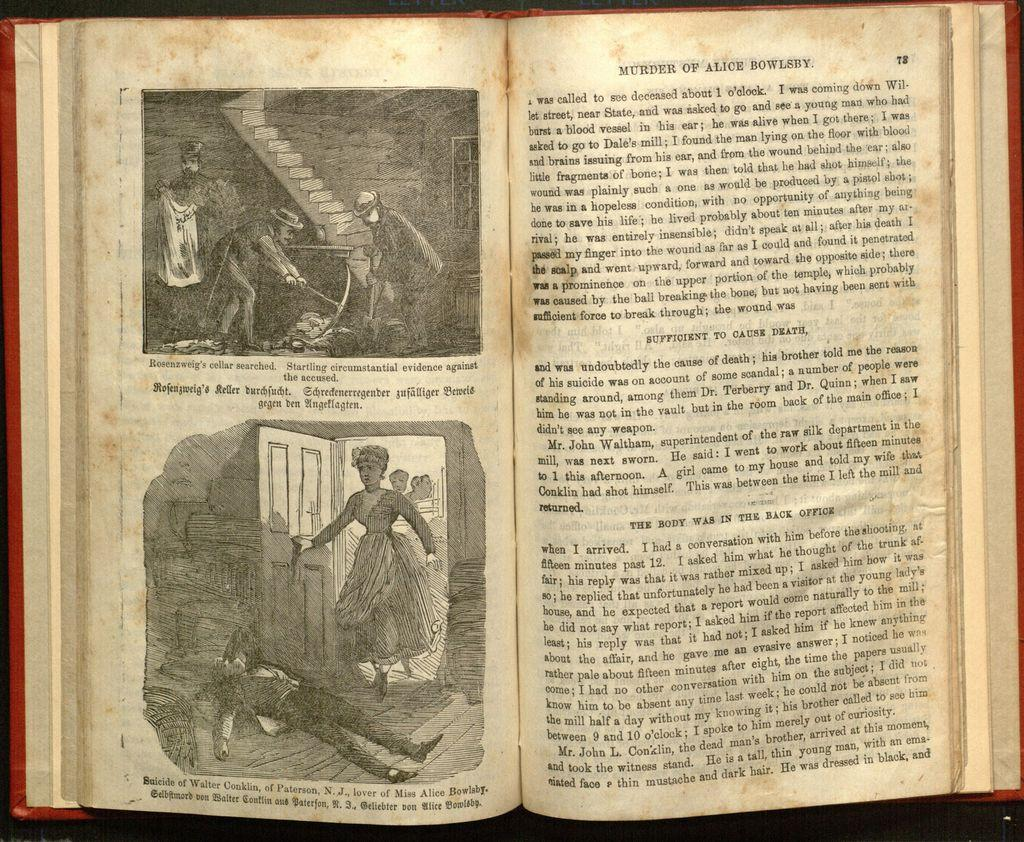<image>
Offer a succinct explanation of the picture presented. A open old book with a pages titled Murder by Alice Bowleby. 